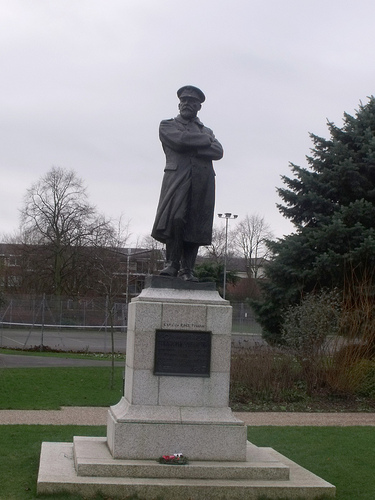<image>
Can you confirm if the plant is to the left of the statue? No. The plant is not to the left of the statue. From this viewpoint, they have a different horizontal relationship. 